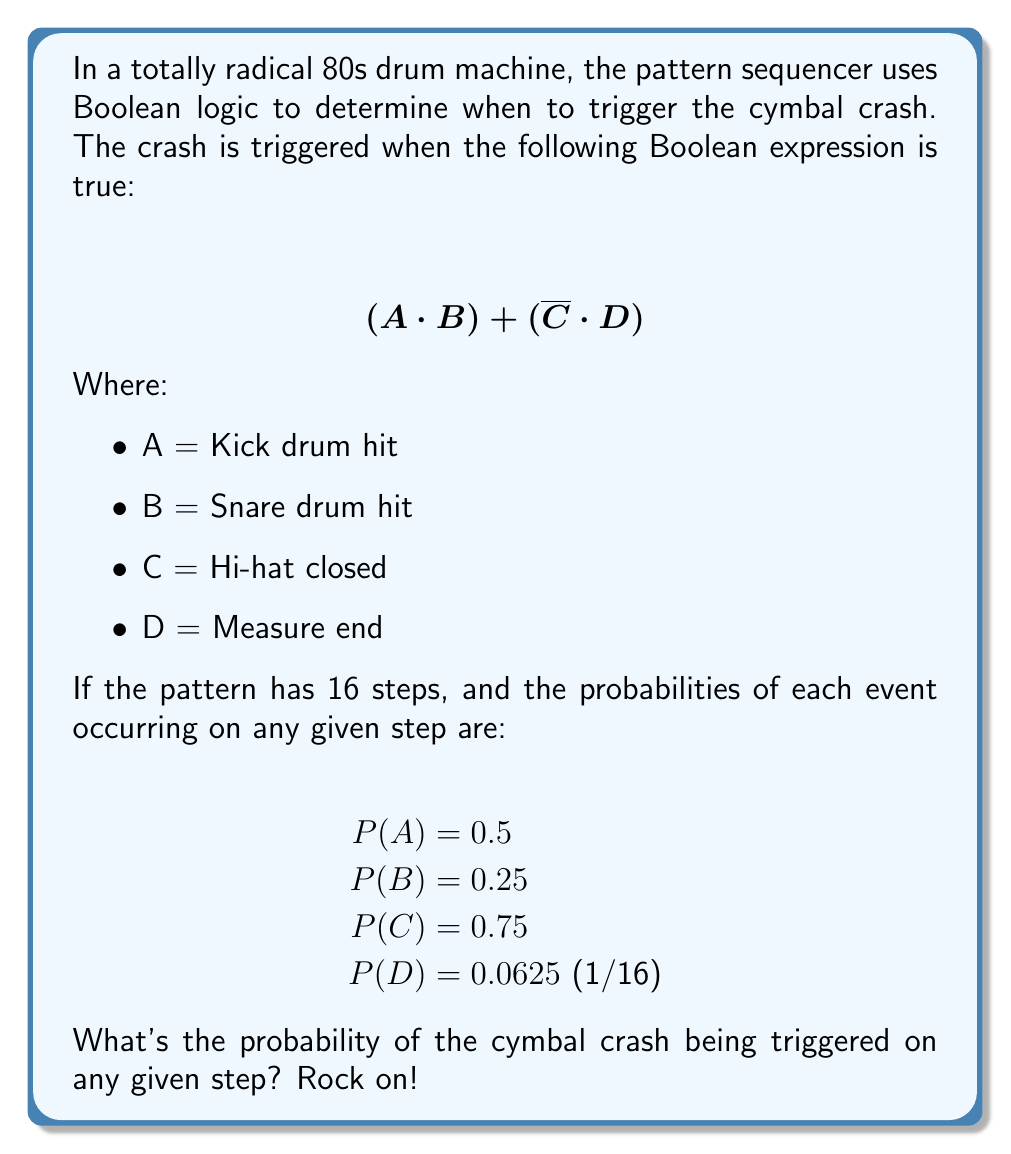Give your solution to this math problem. Alright, headbangers! Let's break this down step by step:

1) We need to find P((A · B) + (C̄ · D)). This is a union of two events, so we'll use the addition rule of probability.

2) P((A · B) + (C̄ · D)) = P(A · B) + P(C̄ · D) - P((A · B) · (C̄ · D))

3) Let's calculate each part:

   a) P(A · B) = P(A) · P(B) = 0.5 · 0.25 = 0.125
   
   b) P(C̄ · D) = P(C̄) · P(D) = (1 - P(C)) · P(D) = 0.25 · 0.0625 = 0.015625
   
   c) P((A · B) · (C̄ · D)) = P(A) · P(B) · P(C̄) · P(D) 
                            = 0.5 · 0.25 · 0.25 · 0.0625 = 0.001953125

4) Now, let's plug these values back into our equation:

   P((A · B) + (C̄ · D)) = 0.125 + 0.015625 - 0.001953125 = 0.138671875

5) Therefore, the probability of the cymbal crash being triggered on any given step is approximately 0.1387 or 13.87%.

That's the probability of hearing that sweet, sweet cymbal crash on any step of your 80s drum machine pattern! Keep on rockin'!
Answer: 0.138671875 